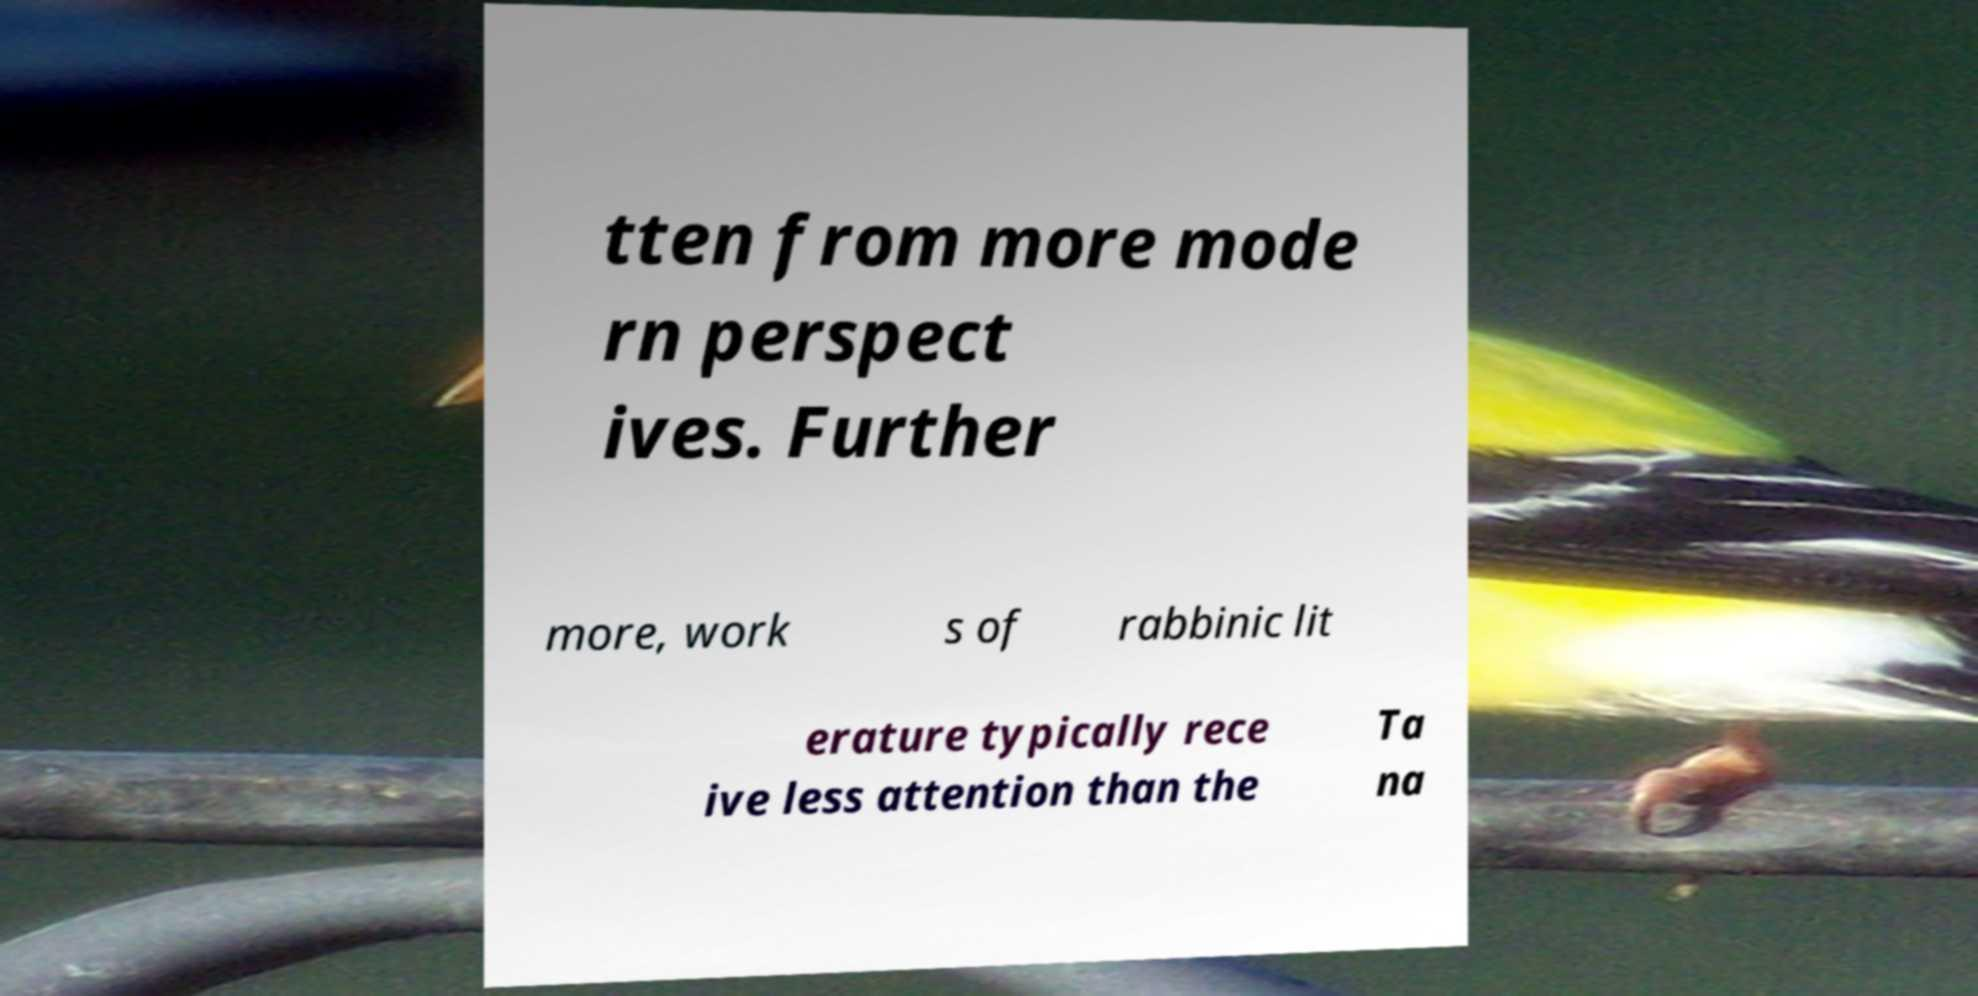Can you accurately transcribe the text from the provided image for me? tten from more mode rn perspect ives. Further more, work s of rabbinic lit erature typically rece ive less attention than the Ta na 